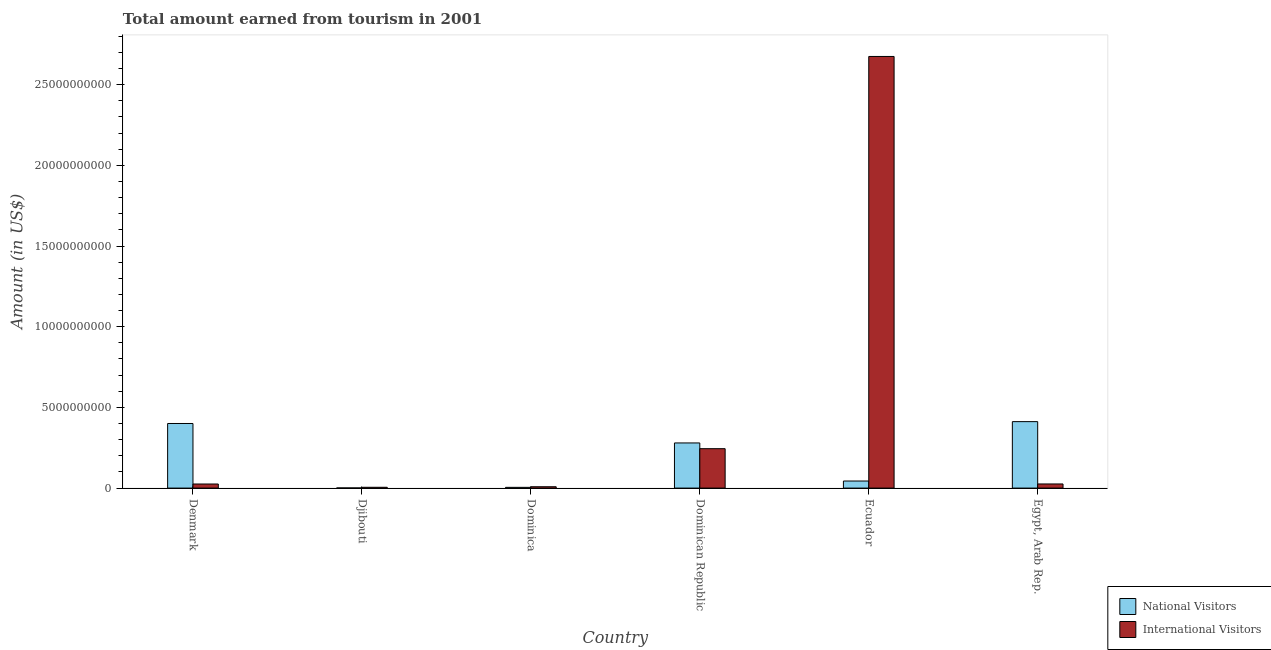How many different coloured bars are there?
Your answer should be compact. 2. Are the number of bars on each tick of the X-axis equal?
Ensure brevity in your answer.  Yes. What is the label of the 2nd group of bars from the left?
Your response must be concise. Djibouti. In how many cases, is the number of bars for a given country not equal to the number of legend labels?
Provide a short and direct response. 0. What is the amount earned from international visitors in Ecuador?
Keep it short and to the point. 2.67e+1. Across all countries, what is the maximum amount earned from international visitors?
Make the answer very short. 2.67e+1. Across all countries, what is the minimum amount earned from international visitors?
Make the answer very short. 5.00e+07. In which country was the amount earned from national visitors maximum?
Ensure brevity in your answer.  Egypt, Arab Rep. In which country was the amount earned from international visitors minimum?
Your response must be concise. Djibouti. What is the total amount earned from national visitors in the graph?
Your answer should be compact. 1.14e+1. What is the difference between the amount earned from national visitors in Djibouti and that in Egypt, Arab Rep.?
Your answer should be compact. -4.11e+09. What is the difference between the amount earned from international visitors in Denmark and the amount earned from national visitors in Ecuador?
Your answer should be compact. -1.85e+08. What is the average amount earned from national visitors per country?
Provide a short and direct response. 1.90e+09. What is the difference between the amount earned from international visitors and amount earned from national visitors in Djibouti?
Make the answer very short. 4.14e+07. What is the ratio of the amount earned from international visitors in Denmark to that in Ecuador?
Your answer should be very brief. 0.01. Is the difference between the amount earned from national visitors in Dominica and Egypt, Arab Rep. greater than the difference between the amount earned from international visitors in Dominica and Egypt, Arab Rep.?
Ensure brevity in your answer.  No. What is the difference between the highest and the second highest amount earned from international visitors?
Make the answer very short. 2.43e+1. What is the difference between the highest and the lowest amount earned from international visitors?
Provide a short and direct response. 2.67e+1. In how many countries, is the amount earned from national visitors greater than the average amount earned from national visitors taken over all countries?
Your response must be concise. 3. What does the 1st bar from the left in Djibouti represents?
Your answer should be compact. National Visitors. What does the 2nd bar from the right in Egypt, Arab Rep. represents?
Ensure brevity in your answer.  National Visitors. How many bars are there?
Your answer should be very brief. 12. How many countries are there in the graph?
Give a very brief answer. 6. What is the difference between two consecutive major ticks on the Y-axis?
Provide a succinct answer. 5.00e+09. Are the values on the major ticks of Y-axis written in scientific E-notation?
Provide a succinct answer. No. Does the graph contain any zero values?
Give a very brief answer. No. Does the graph contain grids?
Keep it short and to the point. No. How are the legend labels stacked?
Your response must be concise. Vertical. What is the title of the graph?
Provide a succinct answer. Total amount earned from tourism in 2001. Does "By country of origin" appear as one of the legend labels in the graph?
Make the answer very short. No. What is the label or title of the Y-axis?
Offer a very short reply. Amount (in US$). What is the Amount (in US$) in National Visitors in Denmark?
Keep it short and to the point. 4.00e+09. What is the Amount (in US$) of International Visitors in Denmark?
Provide a short and direct response. 2.53e+08. What is the Amount (in US$) of National Visitors in Djibouti?
Your answer should be compact. 8.60e+06. What is the Amount (in US$) of National Visitors in Dominica?
Your response must be concise. 4.60e+07. What is the Amount (in US$) in International Visitors in Dominica?
Your answer should be very brief. 8.40e+07. What is the Amount (in US$) in National Visitors in Dominican Republic?
Provide a short and direct response. 2.80e+09. What is the Amount (in US$) in International Visitors in Dominican Republic?
Ensure brevity in your answer.  2.44e+09. What is the Amount (in US$) of National Visitors in Ecuador?
Keep it short and to the point. 4.38e+08. What is the Amount (in US$) in International Visitors in Ecuador?
Provide a succinct answer. 2.67e+1. What is the Amount (in US$) of National Visitors in Egypt, Arab Rep.?
Your response must be concise. 4.12e+09. What is the Amount (in US$) of International Visitors in Egypt, Arab Rep.?
Ensure brevity in your answer.  2.56e+08. Across all countries, what is the maximum Amount (in US$) of National Visitors?
Your answer should be compact. 4.12e+09. Across all countries, what is the maximum Amount (in US$) of International Visitors?
Offer a terse response. 2.67e+1. Across all countries, what is the minimum Amount (in US$) in National Visitors?
Give a very brief answer. 8.60e+06. What is the total Amount (in US$) of National Visitors in the graph?
Provide a short and direct response. 1.14e+1. What is the total Amount (in US$) of International Visitors in the graph?
Your response must be concise. 2.98e+1. What is the difference between the Amount (in US$) of National Visitors in Denmark and that in Djibouti?
Your answer should be very brief. 3.99e+09. What is the difference between the Amount (in US$) of International Visitors in Denmark and that in Djibouti?
Make the answer very short. 2.03e+08. What is the difference between the Amount (in US$) in National Visitors in Denmark and that in Dominica?
Your response must be concise. 3.96e+09. What is the difference between the Amount (in US$) of International Visitors in Denmark and that in Dominica?
Provide a succinct answer. 1.69e+08. What is the difference between the Amount (in US$) of National Visitors in Denmark and that in Dominican Republic?
Offer a very short reply. 1.20e+09. What is the difference between the Amount (in US$) in International Visitors in Denmark and that in Dominican Republic?
Your response must be concise. -2.19e+09. What is the difference between the Amount (in US$) in National Visitors in Denmark and that in Ecuador?
Keep it short and to the point. 3.56e+09. What is the difference between the Amount (in US$) in International Visitors in Denmark and that in Ecuador?
Offer a terse response. -2.65e+1. What is the difference between the Amount (in US$) of National Visitors in Denmark and that in Egypt, Arab Rep.?
Your answer should be compact. -1.16e+08. What is the difference between the Amount (in US$) in National Visitors in Djibouti and that in Dominica?
Your answer should be very brief. -3.74e+07. What is the difference between the Amount (in US$) in International Visitors in Djibouti and that in Dominica?
Your answer should be very brief. -3.40e+07. What is the difference between the Amount (in US$) in National Visitors in Djibouti and that in Dominican Republic?
Offer a terse response. -2.79e+09. What is the difference between the Amount (in US$) of International Visitors in Djibouti and that in Dominican Republic?
Your answer should be compact. -2.39e+09. What is the difference between the Amount (in US$) in National Visitors in Djibouti and that in Ecuador?
Offer a very short reply. -4.29e+08. What is the difference between the Amount (in US$) of International Visitors in Djibouti and that in Ecuador?
Keep it short and to the point. -2.67e+1. What is the difference between the Amount (in US$) in National Visitors in Djibouti and that in Egypt, Arab Rep.?
Offer a very short reply. -4.11e+09. What is the difference between the Amount (in US$) in International Visitors in Djibouti and that in Egypt, Arab Rep.?
Provide a succinct answer. -2.06e+08. What is the difference between the Amount (in US$) of National Visitors in Dominica and that in Dominican Republic?
Keep it short and to the point. -2.75e+09. What is the difference between the Amount (in US$) of International Visitors in Dominica and that in Dominican Republic?
Offer a terse response. -2.36e+09. What is the difference between the Amount (in US$) of National Visitors in Dominica and that in Ecuador?
Offer a very short reply. -3.92e+08. What is the difference between the Amount (in US$) in International Visitors in Dominica and that in Ecuador?
Your response must be concise. -2.67e+1. What is the difference between the Amount (in US$) in National Visitors in Dominica and that in Egypt, Arab Rep.?
Provide a succinct answer. -4.07e+09. What is the difference between the Amount (in US$) in International Visitors in Dominica and that in Egypt, Arab Rep.?
Your response must be concise. -1.72e+08. What is the difference between the Amount (in US$) of National Visitors in Dominican Republic and that in Ecuador?
Your answer should be compact. 2.36e+09. What is the difference between the Amount (in US$) in International Visitors in Dominican Republic and that in Ecuador?
Your response must be concise. -2.43e+1. What is the difference between the Amount (in US$) of National Visitors in Dominican Republic and that in Egypt, Arab Rep.?
Offer a terse response. -1.32e+09. What is the difference between the Amount (in US$) in International Visitors in Dominican Republic and that in Egypt, Arab Rep.?
Keep it short and to the point. 2.19e+09. What is the difference between the Amount (in US$) in National Visitors in Ecuador and that in Egypt, Arab Rep.?
Provide a succinct answer. -3.68e+09. What is the difference between the Amount (in US$) of International Visitors in Ecuador and that in Egypt, Arab Rep.?
Give a very brief answer. 2.65e+1. What is the difference between the Amount (in US$) in National Visitors in Denmark and the Amount (in US$) in International Visitors in Djibouti?
Provide a succinct answer. 3.95e+09. What is the difference between the Amount (in US$) in National Visitors in Denmark and the Amount (in US$) in International Visitors in Dominica?
Offer a terse response. 3.92e+09. What is the difference between the Amount (in US$) in National Visitors in Denmark and the Amount (in US$) in International Visitors in Dominican Republic?
Keep it short and to the point. 1.56e+09. What is the difference between the Amount (in US$) of National Visitors in Denmark and the Amount (in US$) of International Visitors in Ecuador?
Your answer should be very brief. -2.27e+1. What is the difference between the Amount (in US$) in National Visitors in Denmark and the Amount (in US$) in International Visitors in Egypt, Arab Rep.?
Offer a very short reply. 3.75e+09. What is the difference between the Amount (in US$) in National Visitors in Djibouti and the Amount (in US$) in International Visitors in Dominica?
Ensure brevity in your answer.  -7.54e+07. What is the difference between the Amount (in US$) in National Visitors in Djibouti and the Amount (in US$) in International Visitors in Dominican Republic?
Make the answer very short. -2.43e+09. What is the difference between the Amount (in US$) of National Visitors in Djibouti and the Amount (in US$) of International Visitors in Ecuador?
Your answer should be compact. -2.67e+1. What is the difference between the Amount (in US$) of National Visitors in Djibouti and the Amount (in US$) of International Visitors in Egypt, Arab Rep.?
Your response must be concise. -2.47e+08. What is the difference between the Amount (in US$) of National Visitors in Dominica and the Amount (in US$) of International Visitors in Dominican Republic?
Your response must be concise. -2.40e+09. What is the difference between the Amount (in US$) of National Visitors in Dominica and the Amount (in US$) of International Visitors in Ecuador?
Your response must be concise. -2.67e+1. What is the difference between the Amount (in US$) in National Visitors in Dominica and the Amount (in US$) in International Visitors in Egypt, Arab Rep.?
Your answer should be very brief. -2.10e+08. What is the difference between the Amount (in US$) in National Visitors in Dominican Republic and the Amount (in US$) in International Visitors in Ecuador?
Offer a very short reply. -2.40e+1. What is the difference between the Amount (in US$) of National Visitors in Dominican Republic and the Amount (in US$) of International Visitors in Egypt, Arab Rep.?
Your response must be concise. 2.54e+09. What is the difference between the Amount (in US$) of National Visitors in Ecuador and the Amount (in US$) of International Visitors in Egypt, Arab Rep.?
Give a very brief answer. 1.82e+08. What is the average Amount (in US$) of National Visitors per country?
Give a very brief answer. 1.90e+09. What is the average Amount (in US$) in International Visitors per country?
Offer a very short reply. 4.97e+09. What is the difference between the Amount (in US$) of National Visitors and Amount (in US$) of International Visitors in Denmark?
Give a very brief answer. 3.75e+09. What is the difference between the Amount (in US$) of National Visitors and Amount (in US$) of International Visitors in Djibouti?
Offer a terse response. -4.14e+07. What is the difference between the Amount (in US$) of National Visitors and Amount (in US$) of International Visitors in Dominica?
Provide a succinct answer. -3.80e+07. What is the difference between the Amount (in US$) of National Visitors and Amount (in US$) of International Visitors in Dominican Republic?
Offer a very short reply. 3.56e+08. What is the difference between the Amount (in US$) of National Visitors and Amount (in US$) of International Visitors in Ecuador?
Give a very brief answer. -2.63e+1. What is the difference between the Amount (in US$) in National Visitors and Amount (in US$) in International Visitors in Egypt, Arab Rep.?
Make the answer very short. 3.86e+09. What is the ratio of the Amount (in US$) of National Visitors in Denmark to that in Djibouti?
Your response must be concise. 465.47. What is the ratio of the Amount (in US$) in International Visitors in Denmark to that in Djibouti?
Your answer should be compact. 5.06. What is the ratio of the Amount (in US$) of National Visitors in Denmark to that in Dominica?
Offer a terse response. 87.02. What is the ratio of the Amount (in US$) in International Visitors in Denmark to that in Dominica?
Your answer should be very brief. 3.01. What is the ratio of the Amount (in US$) of National Visitors in Denmark to that in Dominican Republic?
Your answer should be very brief. 1.43. What is the ratio of the Amount (in US$) of International Visitors in Denmark to that in Dominican Republic?
Offer a very short reply. 0.1. What is the ratio of the Amount (in US$) in National Visitors in Denmark to that in Ecuador?
Ensure brevity in your answer.  9.14. What is the ratio of the Amount (in US$) in International Visitors in Denmark to that in Ecuador?
Offer a very short reply. 0.01. What is the ratio of the Amount (in US$) of National Visitors in Denmark to that in Egypt, Arab Rep.?
Offer a terse response. 0.97. What is the ratio of the Amount (in US$) in International Visitors in Denmark to that in Egypt, Arab Rep.?
Your answer should be very brief. 0.99. What is the ratio of the Amount (in US$) of National Visitors in Djibouti to that in Dominica?
Offer a very short reply. 0.19. What is the ratio of the Amount (in US$) of International Visitors in Djibouti to that in Dominica?
Provide a succinct answer. 0.6. What is the ratio of the Amount (in US$) in National Visitors in Djibouti to that in Dominican Republic?
Provide a succinct answer. 0. What is the ratio of the Amount (in US$) in International Visitors in Djibouti to that in Dominican Republic?
Your answer should be compact. 0.02. What is the ratio of the Amount (in US$) in National Visitors in Djibouti to that in Ecuador?
Offer a very short reply. 0.02. What is the ratio of the Amount (in US$) of International Visitors in Djibouti to that in Ecuador?
Keep it short and to the point. 0. What is the ratio of the Amount (in US$) in National Visitors in Djibouti to that in Egypt, Arab Rep.?
Your answer should be compact. 0. What is the ratio of the Amount (in US$) of International Visitors in Djibouti to that in Egypt, Arab Rep.?
Ensure brevity in your answer.  0.2. What is the ratio of the Amount (in US$) in National Visitors in Dominica to that in Dominican Republic?
Make the answer very short. 0.02. What is the ratio of the Amount (in US$) of International Visitors in Dominica to that in Dominican Republic?
Provide a succinct answer. 0.03. What is the ratio of the Amount (in US$) of National Visitors in Dominica to that in Ecuador?
Offer a terse response. 0.1. What is the ratio of the Amount (in US$) of International Visitors in Dominica to that in Ecuador?
Offer a terse response. 0. What is the ratio of the Amount (in US$) in National Visitors in Dominica to that in Egypt, Arab Rep.?
Give a very brief answer. 0.01. What is the ratio of the Amount (in US$) of International Visitors in Dominica to that in Egypt, Arab Rep.?
Make the answer very short. 0.33. What is the ratio of the Amount (in US$) in National Visitors in Dominican Republic to that in Ecuador?
Provide a short and direct response. 6.39. What is the ratio of the Amount (in US$) in International Visitors in Dominican Republic to that in Ecuador?
Offer a very short reply. 0.09. What is the ratio of the Amount (in US$) of National Visitors in Dominican Republic to that in Egypt, Arab Rep.?
Make the answer very short. 0.68. What is the ratio of the Amount (in US$) in International Visitors in Dominican Republic to that in Egypt, Arab Rep.?
Make the answer very short. 9.54. What is the ratio of the Amount (in US$) in National Visitors in Ecuador to that in Egypt, Arab Rep.?
Offer a very short reply. 0.11. What is the ratio of the Amount (in US$) in International Visitors in Ecuador to that in Egypt, Arab Rep.?
Provide a succinct answer. 104.49. What is the difference between the highest and the second highest Amount (in US$) in National Visitors?
Offer a very short reply. 1.16e+08. What is the difference between the highest and the second highest Amount (in US$) of International Visitors?
Provide a short and direct response. 2.43e+1. What is the difference between the highest and the lowest Amount (in US$) of National Visitors?
Give a very brief answer. 4.11e+09. What is the difference between the highest and the lowest Amount (in US$) in International Visitors?
Offer a terse response. 2.67e+1. 